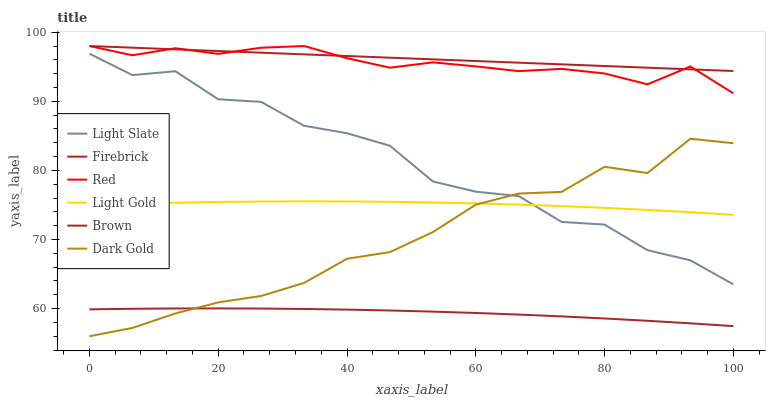Does Brown have the minimum area under the curve?
Answer yes or no. Yes. Does Firebrick have the maximum area under the curve?
Answer yes or no. Yes. Does Dark Gold have the minimum area under the curve?
Answer yes or no. No. Does Dark Gold have the maximum area under the curve?
Answer yes or no. No. Is Firebrick the smoothest?
Answer yes or no. Yes. Is Light Slate the roughest?
Answer yes or no. Yes. Is Dark Gold the smoothest?
Answer yes or no. No. Is Dark Gold the roughest?
Answer yes or no. No. Does Dark Gold have the lowest value?
Answer yes or no. Yes. Does Light Slate have the lowest value?
Answer yes or no. No. Does Red have the highest value?
Answer yes or no. Yes. Does Dark Gold have the highest value?
Answer yes or no. No. Is Brown less than Firebrick?
Answer yes or no. Yes. Is Firebrick greater than Brown?
Answer yes or no. Yes. Does Light Gold intersect Light Slate?
Answer yes or no. Yes. Is Light Gold less than Light Slate?
Answer yes or no. No. Is Light Gold greater than Light Slate?
Answer yes or no. No. Does Brown intersect Firebrick?
Answer yes or no. No. 